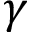Convert formula to latex. <formula><loc_0><loc_0><loc_500><loc_500>\gamma</formula> 